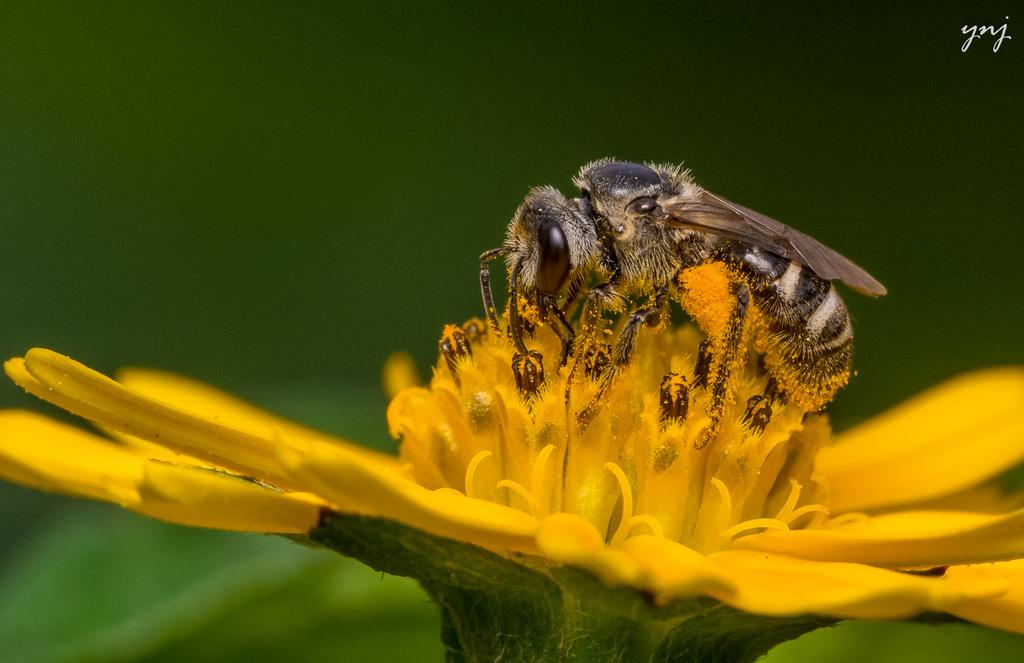What is the main subject of the image? There is a flower in the image. How is the flower depicted in the image? The flower is partially cut off or "truncated." Are there any other living organisms present in the image? Yes, there is an insect on the flower. Is there any text included in the image? Yes, there is text on the image. How would you describe the background of the image? The background of the image is blurred. Where is the coach parked in the image? There is no coach present in the image; it only features a flower, an insect, text, and a blurred background. 